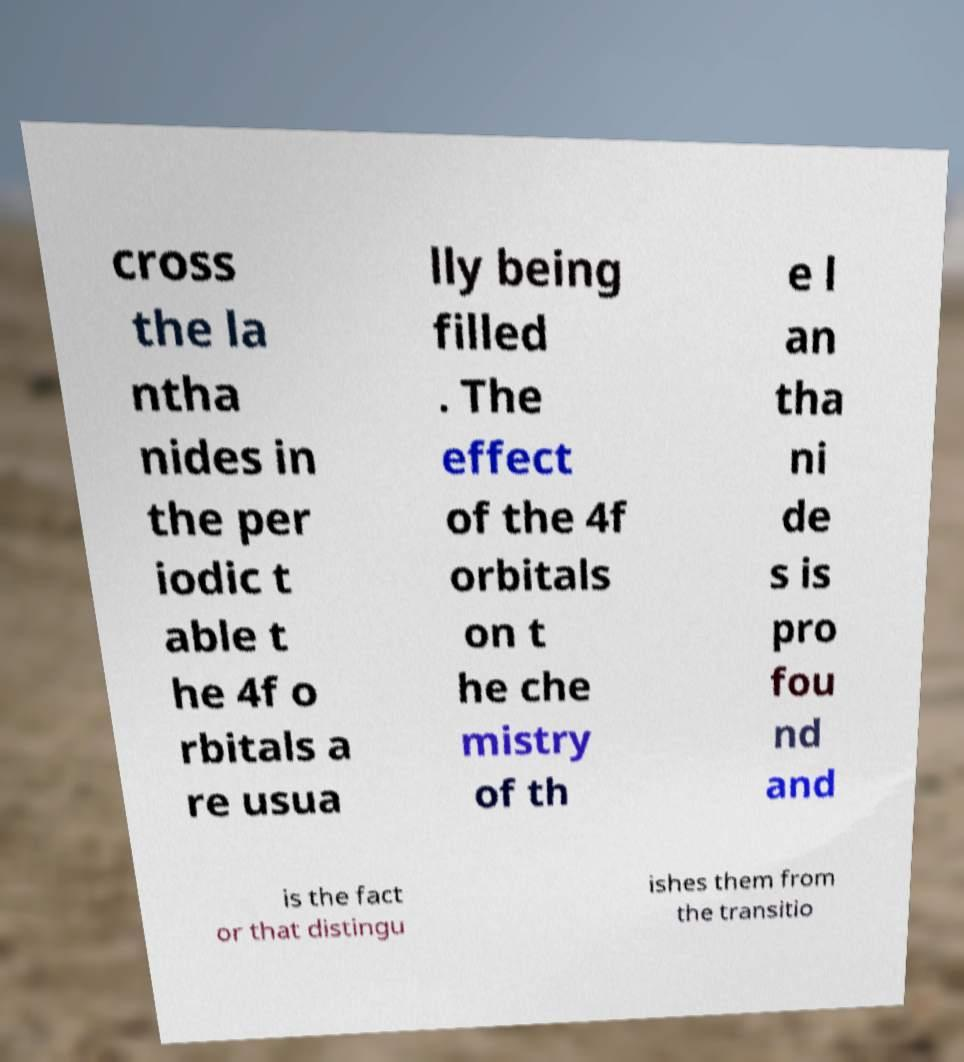What messages or text are displayed in this image? I need them in a readable, typed format. cross the la ntha nides in the per iodic t able t he 4f o rbitals a re usua lly being filled . The effect of the 4f orbitals on t he che mistry of th e l an tha ni de s is pro fou nd and is the fact or that distingu ishes them from the transitio 